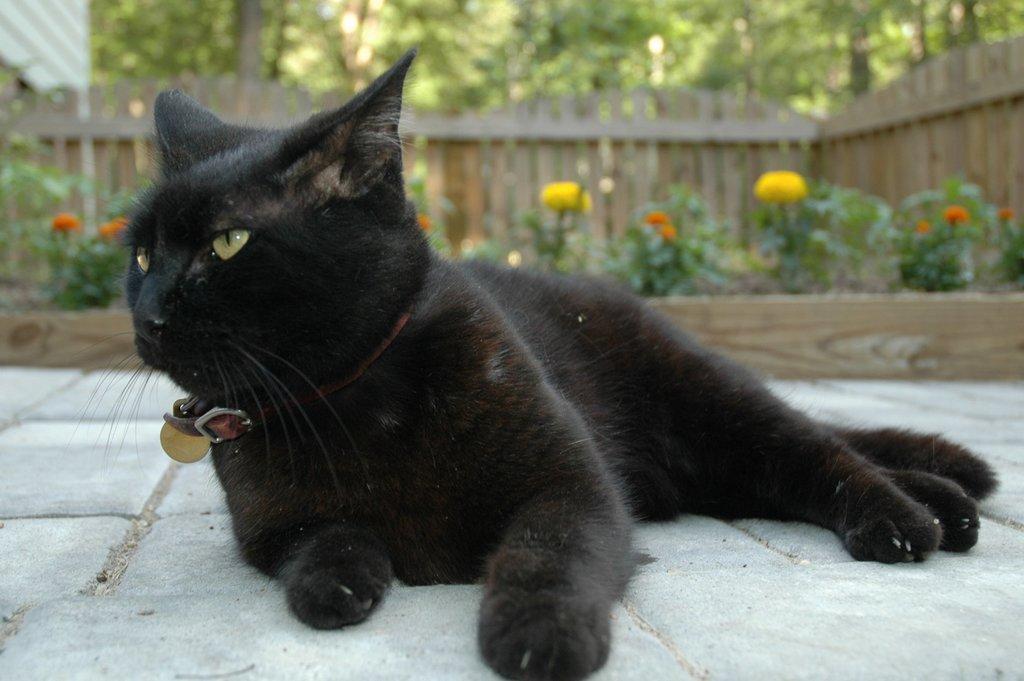Can you describe this image briefly? In the center of the image we can see a cat. In the background there are plants and we can see flowers. There are trees and there is a fence. 